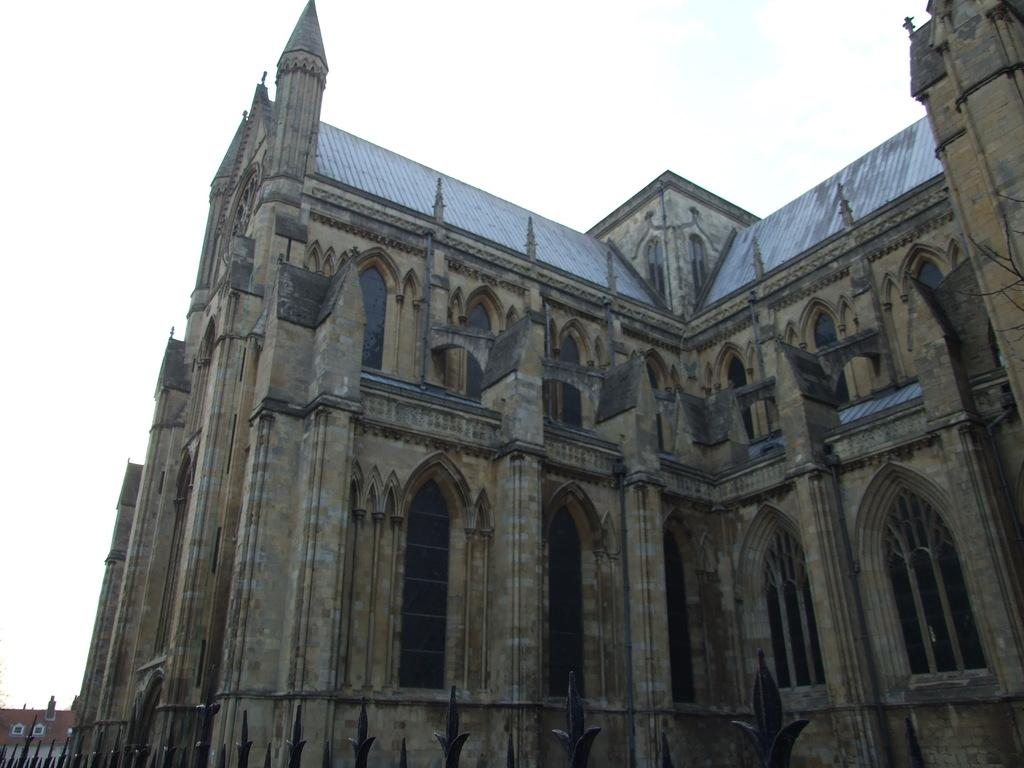What type of structure is depicted in the image? There is an architecture in the image. What can be seen in the background of the image? The sky is visible at the top of the image. What type of bird can be seen flying near the architecture in the image? There is no bird present in the image; only the architecture and sky are visible. What type of vegetable is being used to decorate the architecture in the image? There is no vegetable, such as a yam, present in the image to be used for decoration? 